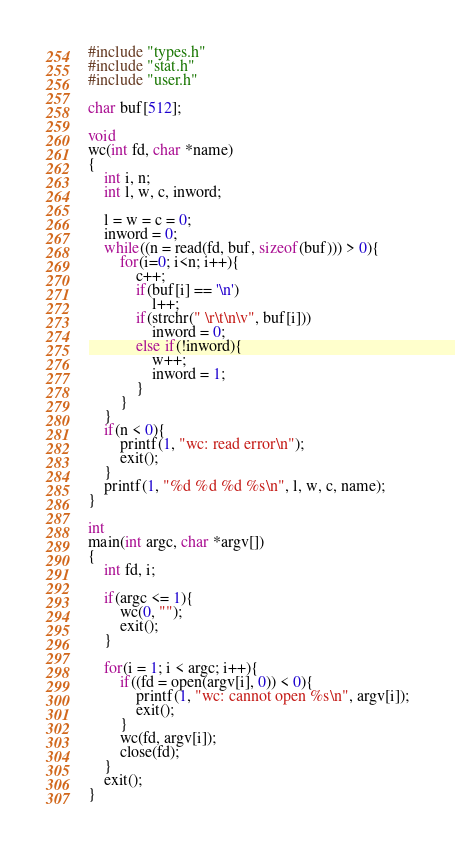Convert code to text. <code><loc_0><loc_0><loc_500><loc_500><_C_>#include "types.h"
#include "stat.h"
#include "user.h"

char buf[512];

void
wc(int fd, char *name)
{
	int i, n;
	int l, w, c, inword;

	l = w = c = 0;
	inword = 0;
	while((n = read(fd, buf, sizeof(buf))) > 0){
		for(i=0; i<n; i++){
			c++;
			if(buf[i] == '\n')
				l++;
			if(strchr(" \r\t\n\v", buf[i]))
				inword = 0;
			else if(!inword){
				w++;
				inword = 1;
			}
		}
	}
	if(n < 0){
		printf(1, "wc: read error\n");
		exit();
	}
	printf(1, "%d %d %d %s\n", l, w, c, name);
}

int
main(int argc, char *argv[])
{
	int fd, i;

	if(argc <= 1){
		wc(0, "");
		exit();
	}

	for(i = 1; i < argc; i++){
		if((fd = open(argv[i], 0)) < 0){
			printf(1, "wc: cannot open %s\n", argv[i]);
			exit();
		}
		wc(fd, argv[i]);
		close(fd);
	}
	exit();
}
</code> 